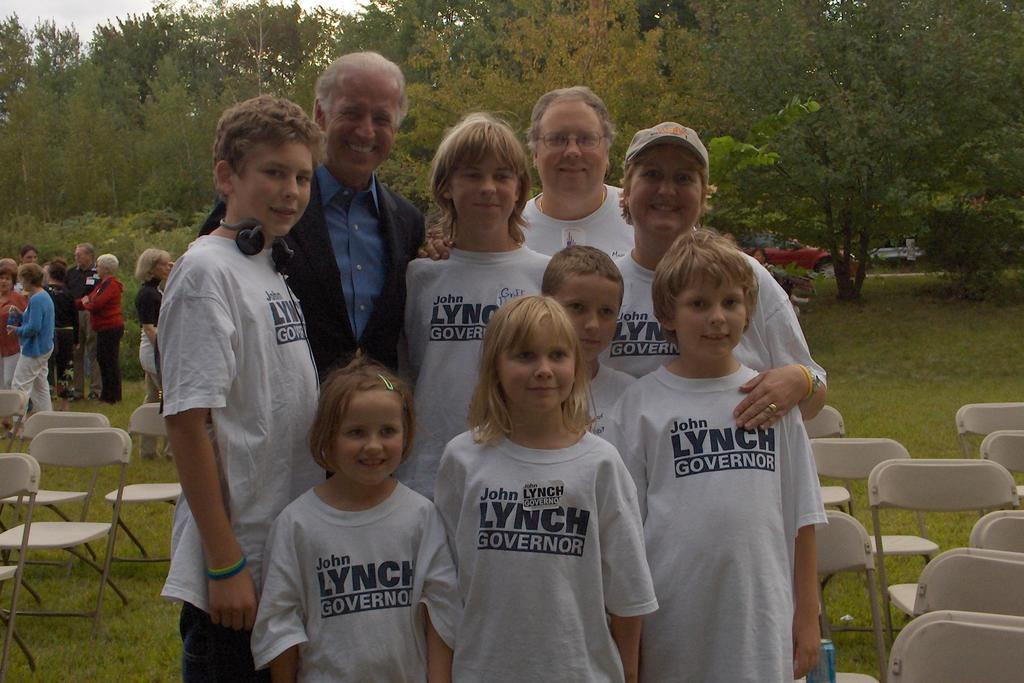What is the main subject of the image? The main subject of the image is a group of people. What are the people wearing in the image? The people are wearing white t-shirts in the image. What can be seen on either side of the group? There are chairs on either side of the group in the image. What type of natural scenery is visible in the background? There are trees at the back of the image. What arithmetic problem are the people trying to solve in the image? There is no arithmetic problem visible in the image; the people are simply standing together. What type of agreement are the people discussing in the image? There is no indication of a discussion or agreement in the image; the people are just wearing white t-shirts and standing near chairs. 